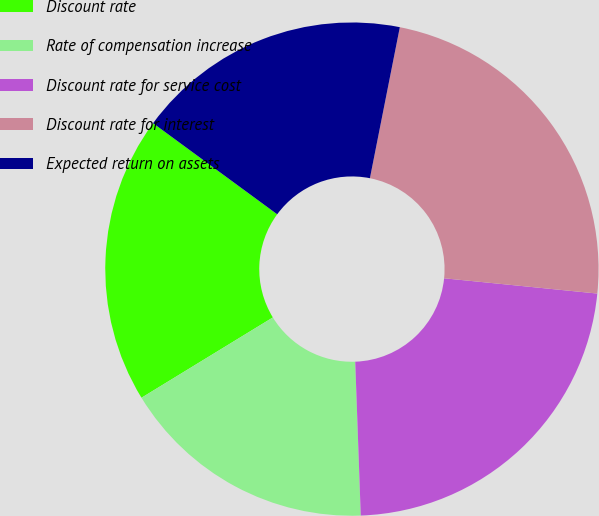Convert chart to OTSL. <chart><loc_0><loc_0><loc_500><loc_500><pie_chart><fcel>Discount rate<fcel>Rate of compensation increase<fcel>Discount rate for service cost<fcel>Discount rate for interest<fcel>Expected return on assets<nl><fcel>18.81%<fcel>16.84%<fcel>22.85%<fcel>23.47%<fcel>18.04%<nl></chart> 